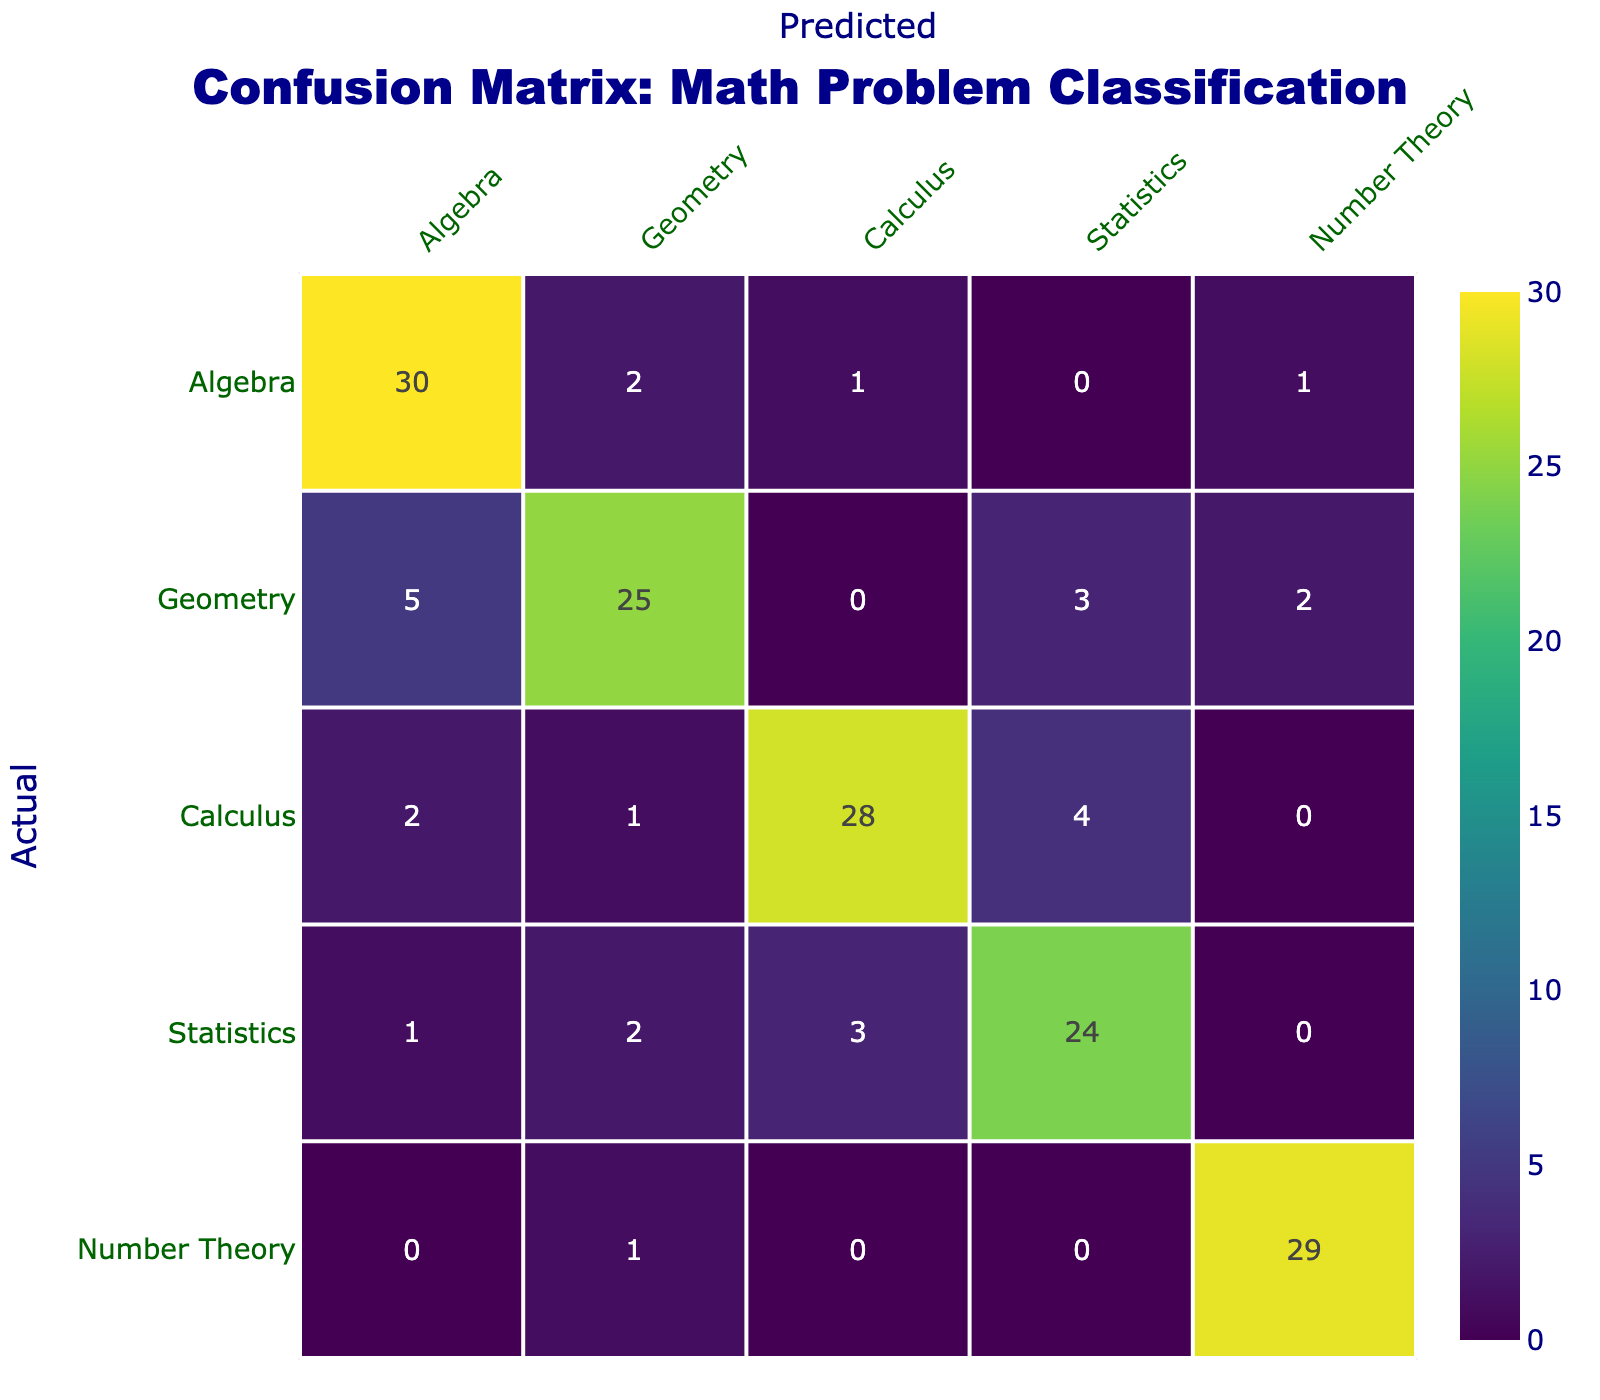What is the number of correctly classified Algebra problems? The number of correctly classified Algebra problems can be found on the diagonal of the matrix, which for Algebra is 30.
Answer: 30 What is the total number of Geometry problems predicted as Algebra? To find this, we look at the Geometry row in the Algebra column, which shows 5 instances where Geometry problems were predicted as Algebra.
Answer: 5 How many Calculus problems were misclassified as Statistics? The value in the Calculus row under the Statistics column indicates the number of misclassified instances, which is 4.
Answer: 4 What is the total number of Algebra problems submitted? To find the total submitted for Algebra, sum the entire Algebra column: 30 (correct) + 2 + 1 + 0 + 1 = 34.
Answer: 34 Is it true that more problems were correctly classified in Geometry than in Statistics? For Geometry, the correctly classified count is 25, and for Statistics, it is 24. Thus, it is true that more problems were correctly classified in Geometry.
Answer: Yes What is the total number of problems predicted as Number Theory? The Number Theory column shows predicted values: 1 (Algebra) + 2 (Geometry) + 0 (Calculus) + 0 (Statistics) + 29 (correct) = 32.
Answer: 32 Which category had the least number of misclassifications? To find this, we analyze each row for misclassifications. The Number Theory row has 1 misclassification (from Geometry), which is the least compared to other categories.
Answer: Number Theory What is the average number of misclassifications per category? First, we calculate the total number of misclassifications by summing up the off-diagonal values: (2+1+0+1) + (5+0+3+2) + (2+1+4+0) + (1+2+3+0) + (0+1+0+0) = 28. Then we divide by the number of categories: 28/5 = 5.6.
Answer: 5.6 Which type of problem had the highest total number of correctly classified instances? To find this, we check the diagonal values: 30 (Algebra), 25 (Geometry), 28 (Calculus), 24 (Statistics), and 29 (Number Theory). The highest is 30 for Algebra.
Answer: Algebra 